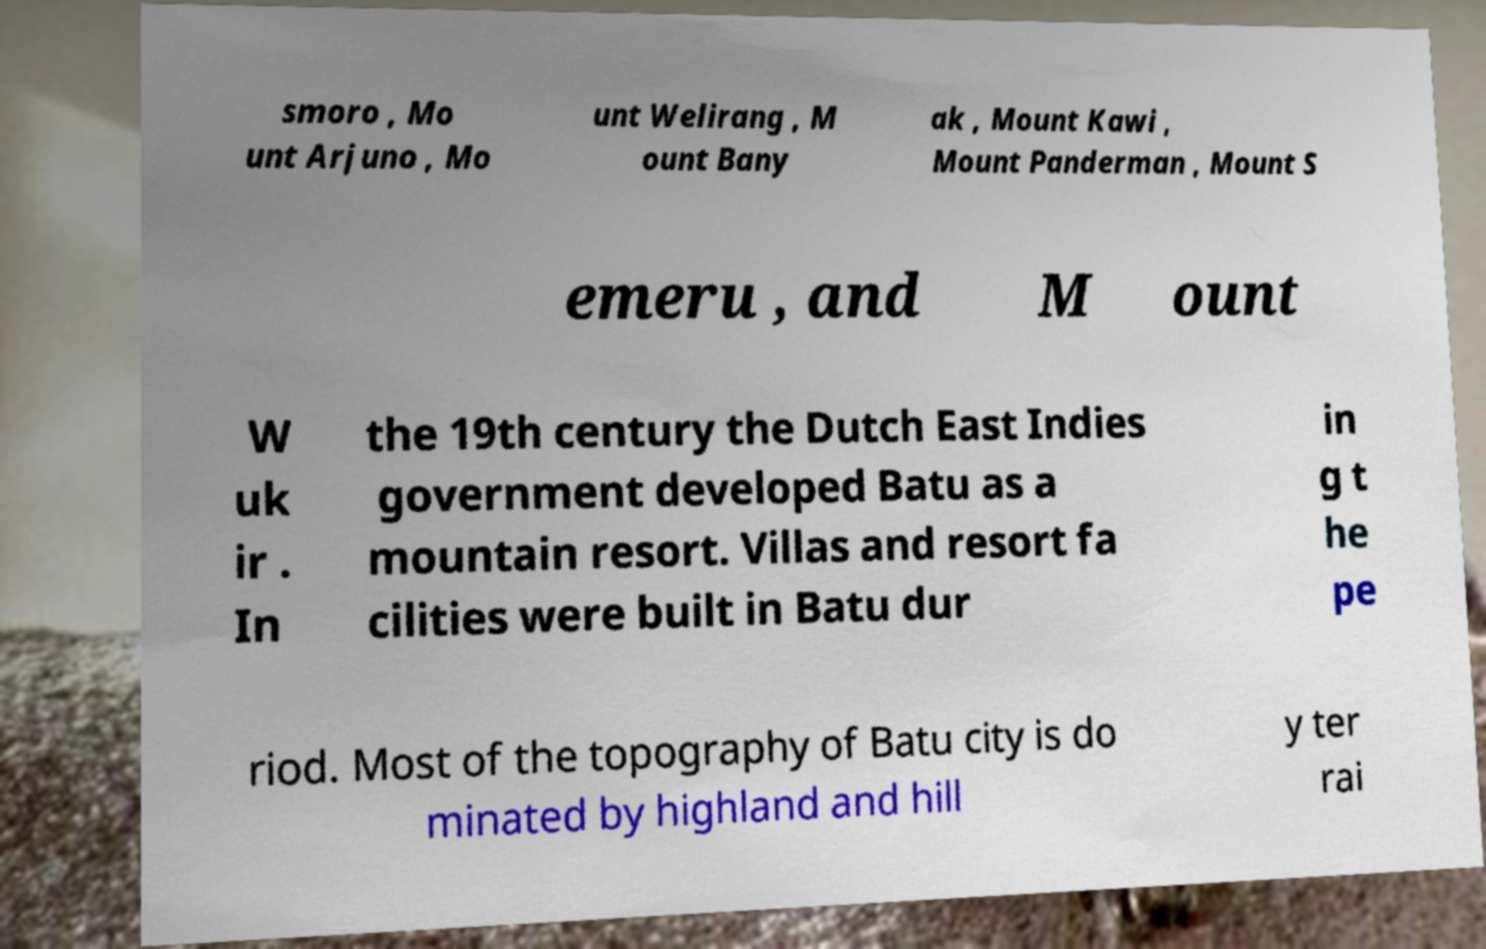Can you read and provide the text displayed in the image?This photo seems to have some interesting text. Can you extract and type it out for me? smoro , Mo unt Arjuno , Mo unt Welirang , M ount Bany ak , Mount Kawi , Mount Panderman , Mount S emeru , and M ount W uk ir . In the 19th century the Dutch East Indies government developed Batu as a mountain resort. Villas and resort fa cilities were built in Batu dur in g t he pe riod. Most of the topography of Batu city is do minated by highland and hill y ter rai 